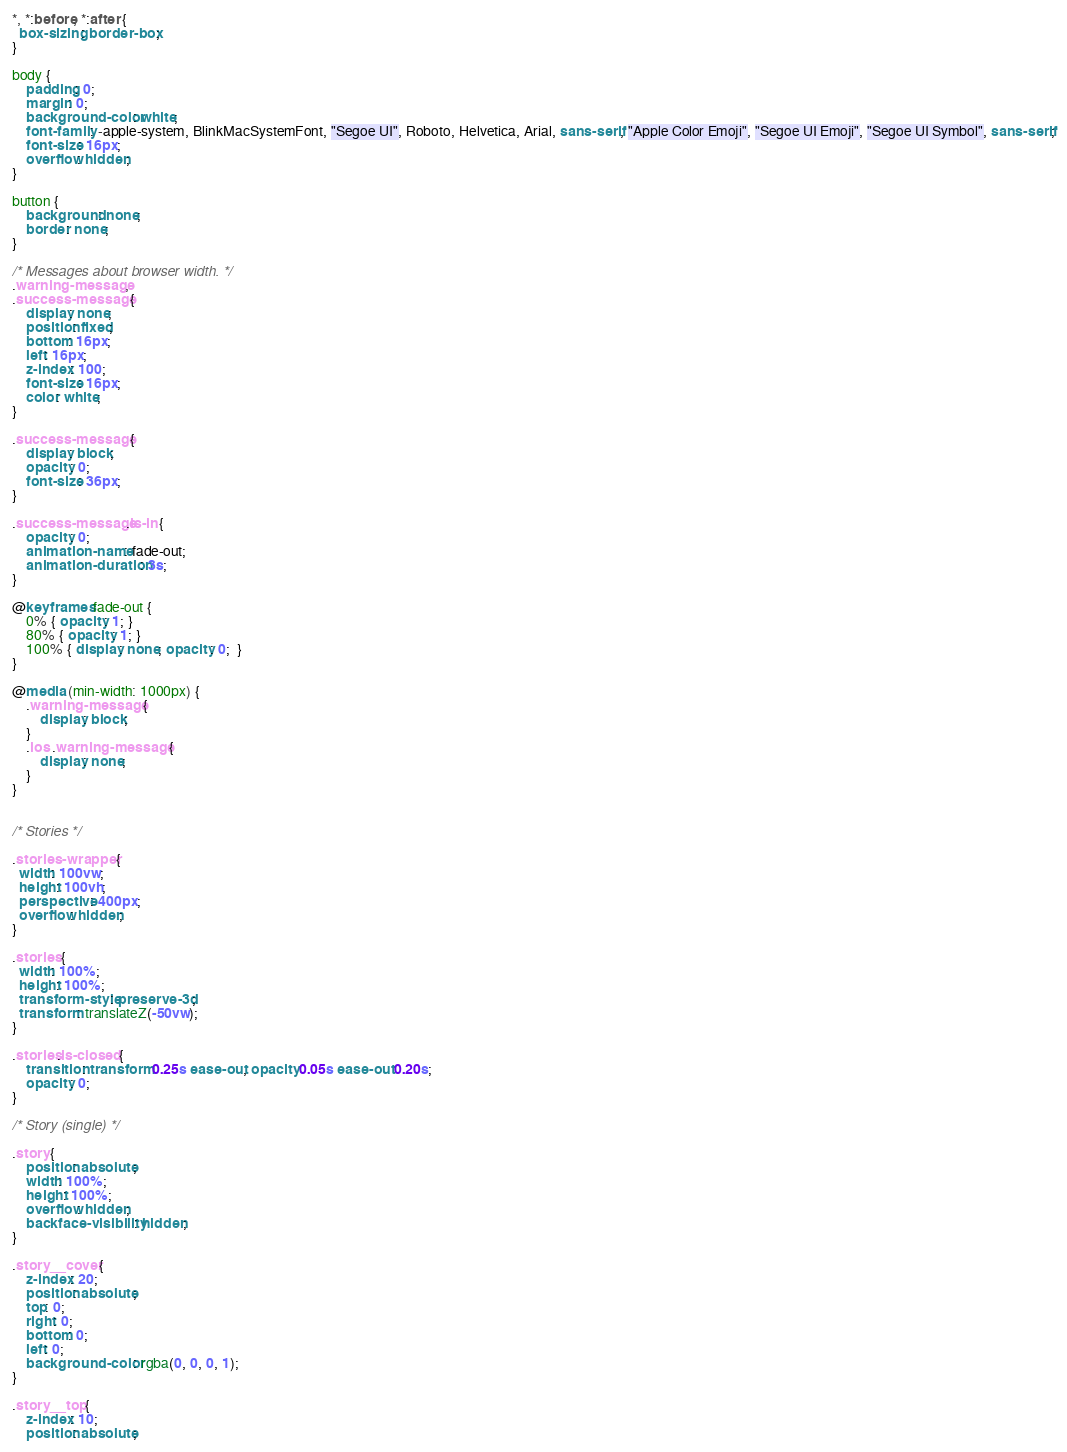<code> <loc_0><loc_0><loc_500><loc_500><_CSS_>*, *:before, *:after {
  box-sizing: border-box;
}

body {
	padding: 0;
	margin: 0;
	background-color: white;
	font-family: -apple-system, BlinkMacSystemFont, "Segoe UI", Roboto, Helvetica, Arial, sans-serif, "Apple Color Emoji", "Segoe UI Emoji", "Segoe UI Symbol", sans-serif;
	font-size: 16px;
	overflow: hidden;
}

button {
	background: none;
	border: none;
}

/* Messages about browser width. */
.warning-message,
.success-message {
	display: none;
	position: fixed;
	bottom: 16px;
	left: 16px;
	z-index: 100;
	font-size: 16px;
	color: white;
}

.success-message {
	display: block;
	opacity: 0;
	font-size: 36px;
}

.success-message.is-in {
	opacity: 0;
	animation-name: fade-out;
	animation-duration: 3s;
}

@keyframes fade-out {
	0% { opacity: 1; }
	80% { opacity: 1; }
	100% { display: none; opacity: 0;  }
}

@media (min-width: 1000px) {
	.warning-message {
		display: block;
	}
	.ios .warning-message {
		display: none;
	}
}


/* Stories */

.stories-wrapper {
  width: 100vw;
  height: 100vh;
  perspective: 400px;
  overflow: hidden;
}

.stories {
  width: 100%;
  height: 100%;
  transform-style: preserve-3d;
  transform: translateZ(-50vw);
}

.stories.is-closed {
	transition: transform 0.25s ease-out, opacity 0.05s ease-out 0.20s;
	opacity: 0;
}

/* Story (single) */

.story {
	position: absolute;
	width: 100%;
	height: 100%;
	overflow: hidden;
	backface-visibility: hidden;
}

.story__cover {
	z-index: 20;
	position: absolute;
	top: 0;
	right: 0;
	bottom: 0;
	left: 0;
	background-color: rgba(0, 0, 0, 1);
}

.story__top {
	z-index: 10;
	position: absolute;</code> 